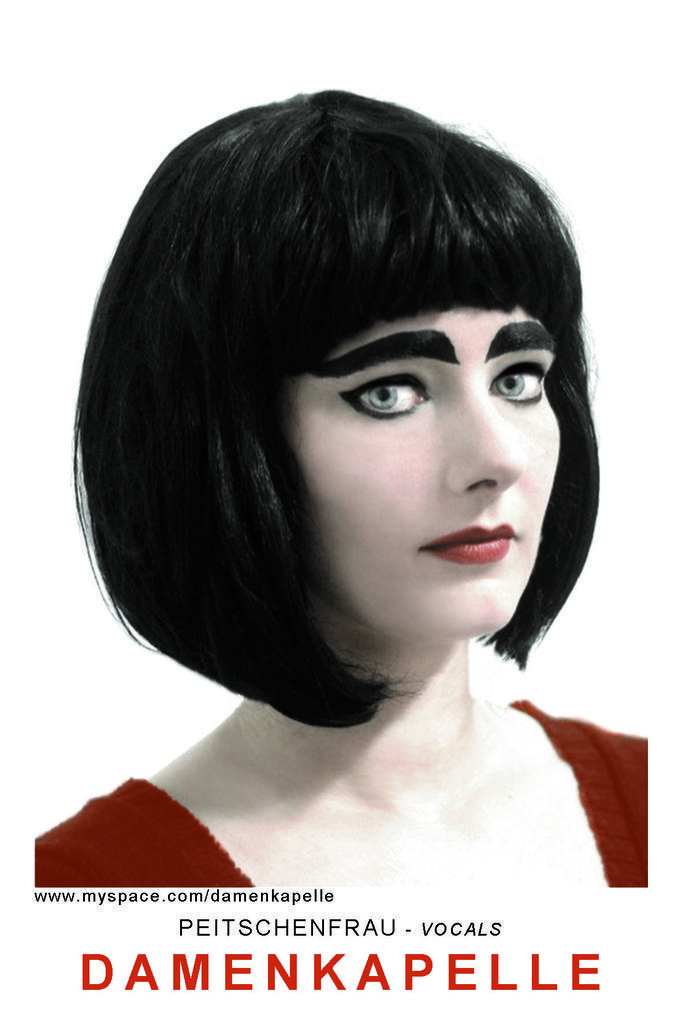Please provide a concise description of this image. In this image we can see pictures of a woman. At the bottom we can see some text. 